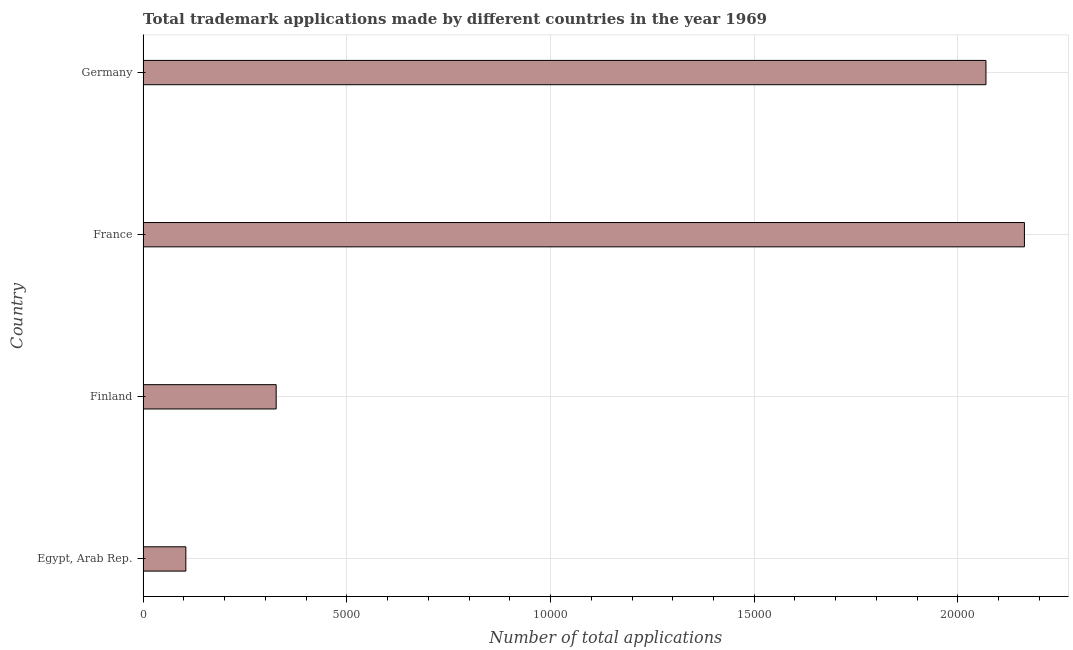What is the title of the graph?
Provide a short and direct response. Total trademark applications made by different countries in the year 1969. What is the label or title of the X-axis?
Keep it short and to the point. Number of total applications. What is the label or title of the Y-axis?
Your response must be concise. Country. What is the number of trademark applications in Germany?
Ensure brevity in your answer.  2.07e+04. Across all countries, what is the maximum number of trademark applications?
Your answer should be compact. 2.16e+04. Across all countries, what is the minimum number of trademark applications?
Provide a succinct answer. 1050. In which country was the number of trademark applications minimum?
Offer a terse response. Egypt, Arab Rep. What is the sum of the number of trademark applications?
Offer a very short reply. 4.66e+04. What is the difference between the number of trademark applications in Egypt, Arab Rep. and France?
Your response must be concise. -2.06e+04. What is the average number of trademark applications per country?
Make the answer very short. 1.17e+04. What is the median number of trademark applications?
Your response must be concise. 1.20e+04. What is the ratio of the number of trademark applications in Finland to that in France?
Provide a short and direct response. 0.15. Is the number of trademark applications in Egypt, Arab Rep. less than that in Finland?
Your response must be concise. Yes. What is the difference between the highest and the second highest number of trademark applications?
Your answer should be very brief. 944. Is the sum of the number of trademark applications in Finland and France greater than the maximum number of trademark applications across all countries?
Keep it short and to the point. Yes. What is the difference between the highest and the lowest number of trademark applications?
Provide a succinct answer. 2.06e+04. In how many countries, is the number of trademark applications greater than the average number of trademark applications taken over all countries?
Give a very brief answer. 2. How many bars are there?
Keep it short and to the point. 4. Are all the bars in the graph horizontal?
Provide a short and direct response. Yes. What is the difference between two consecutive major ticks on the X-axis?
Provide a short and direct response. 5000. What is the Number of total applications in Egypt, Arab Rep.?
Make the answer very short. 1050. What is the Number of total applications in Finland?
Ensure brevity in your answer.  3267. What is the Number of total applications in France?
Your answer should be very brief. 2.16e+04. What is the Number of total applications of Germany?
Keep it short and to the point. 2.07e+04. What is the difference between the Number of total applications in Egypt, Arab Rep. and Finland?
Keep it short and to the point. -2217. What is the difference between the Number of total applications in Egypt, Arab Rep. and France?
Keep it short and to the point. -2.06e+04. What is the difference between the Number of total applications in Egypt, Arab Rep. and Germany?
Ensure brevity in your answer.  -1.96e+04. What is the difference between the Number of total applications in Finland and France?
Provide a succinct answer. -1.84e+04. What is the difference between the Number of total applications in Finland and Germany?
Offer a very short reply. -1.74e+04. What is the difference between the Number of total applications in France and Germany?
Give a very brief answer. 944. What is the ratio of the Number of total applications in Egypt, Arab Rep. to that in Finland?
Offer a very short reply. 0.32. What is the ratio of the Number of total applications in Egypt, Arab Rep. to that in France?
Make the answer very short. 0.05. What is the ratio of the Number of total applications in Egypt, Arab Rep. to that in Germany?
Offer a terse response. 0.05. What is the ratio of the Number of total applications in Finland to that in France?
Offer a very short reply. 0.15. What is the ratio of the Number of total applications in Finland to that in Germany?
Give a very brief answer. 0.16. What is the ratio of the Number of total applications in France to that in Germany?
Ensure brevity in your answer.  1.05. 